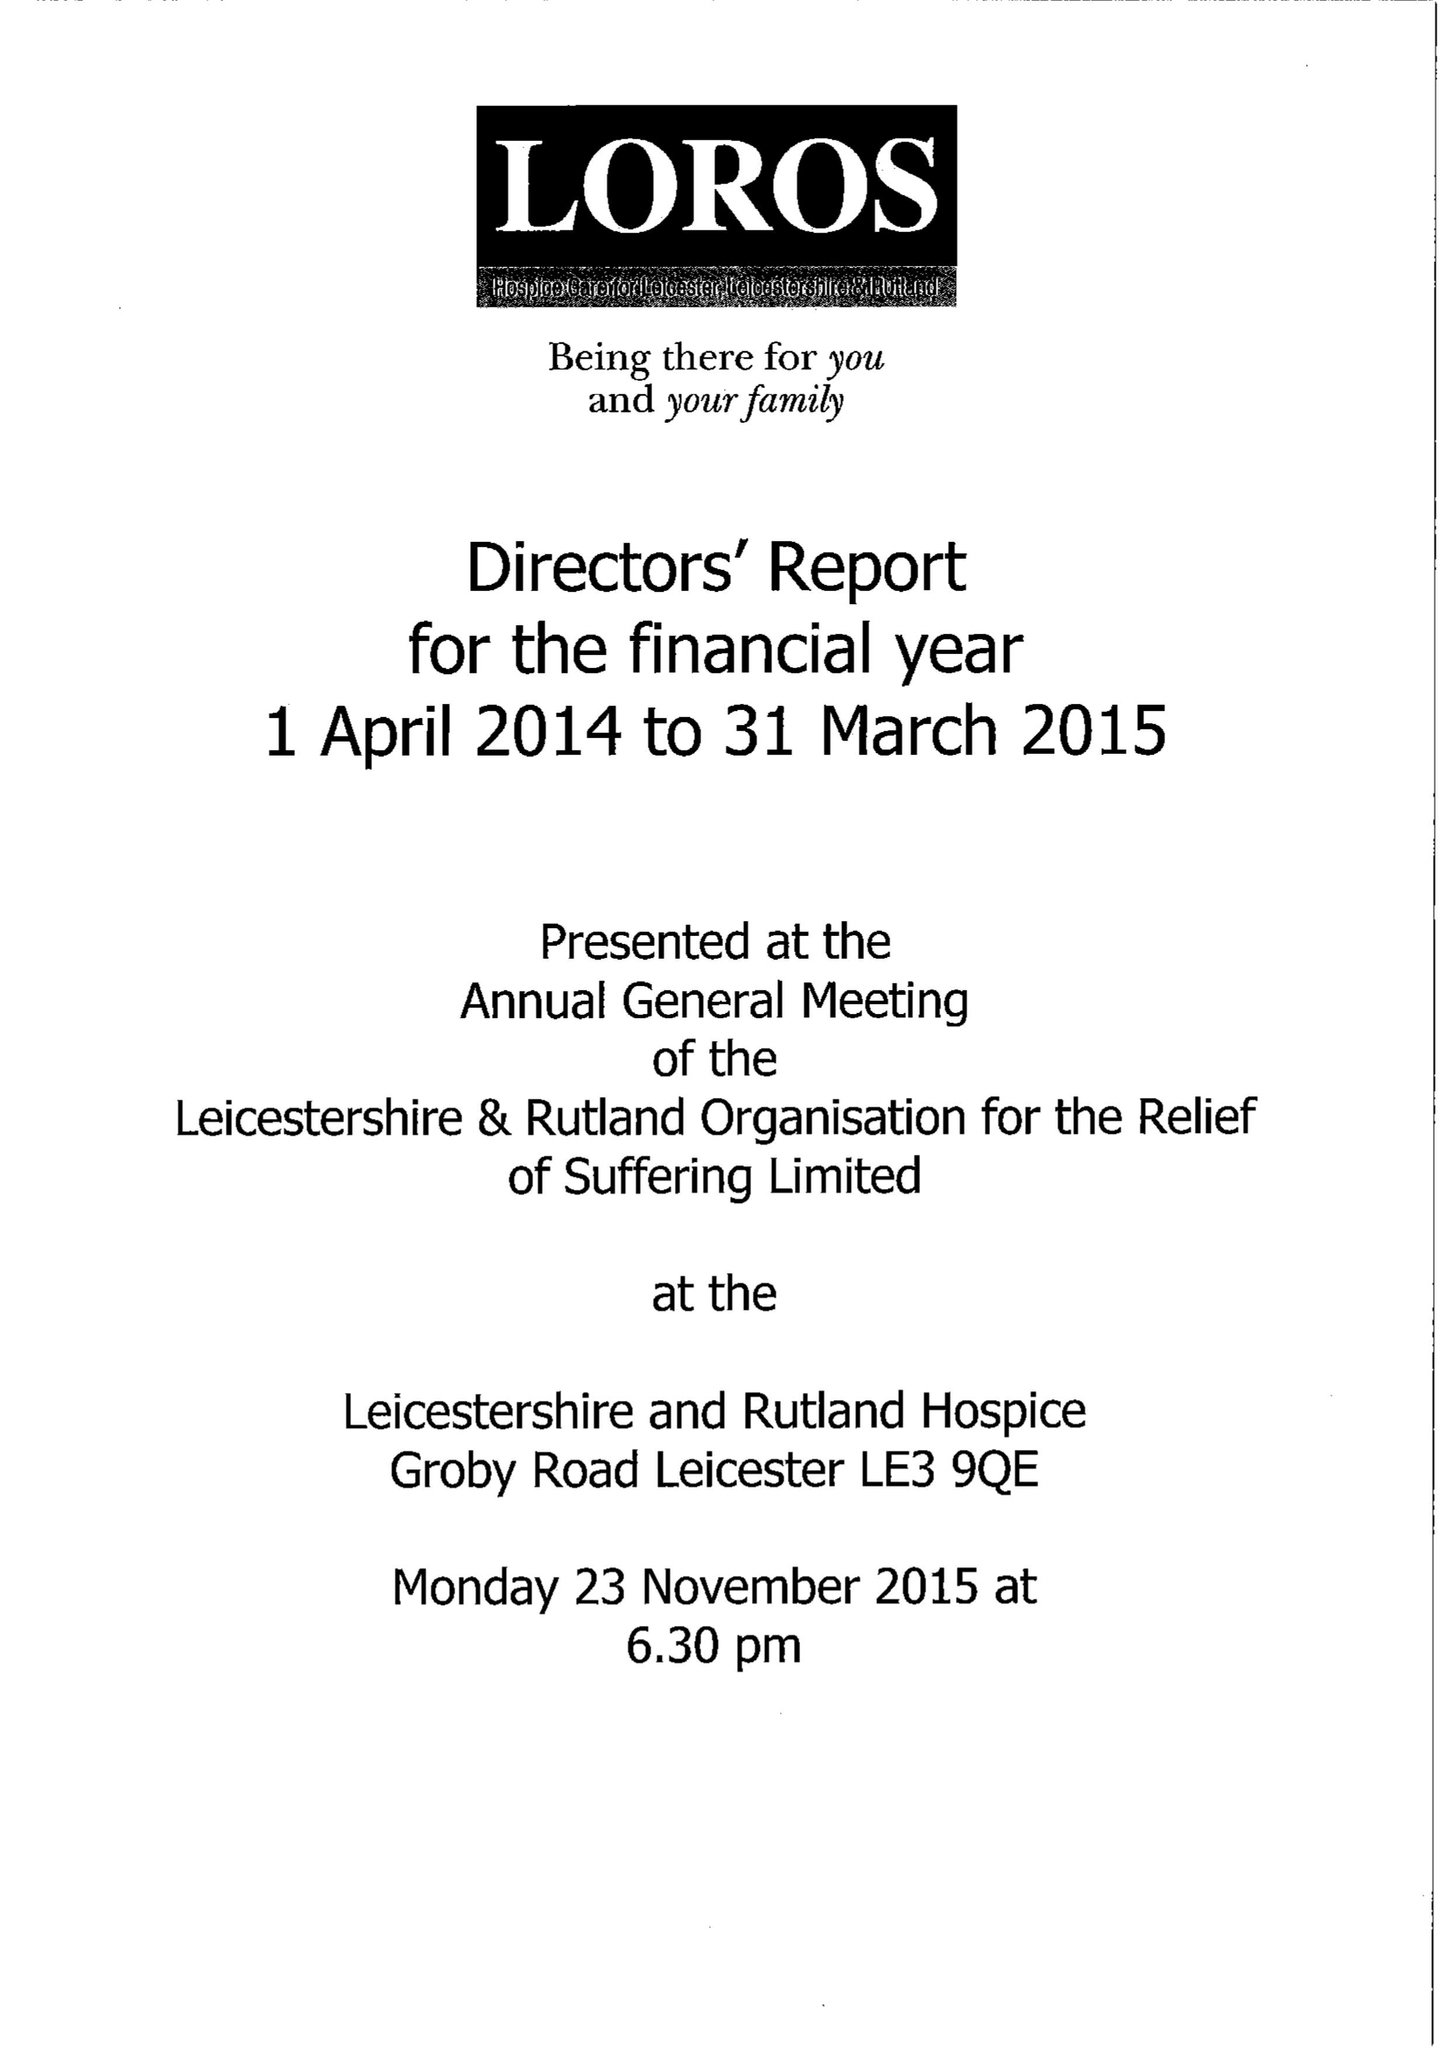What is the value for the report_date?
Answer the question using a single word or phrase. 2015-03-31 